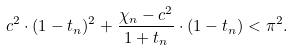<formula> <loc_0><loc_0><loc_500><loc_500>c ^ { 2 } \cdot ( 1 - t _ { n } ) ^ { 2 } + \frac { \chi _ { n } - c ^ { 2 } } { 1 + t _ { n } } \cdot ( 1 - t _ { n } ) < \pi ^ { 2 } .</formula> 